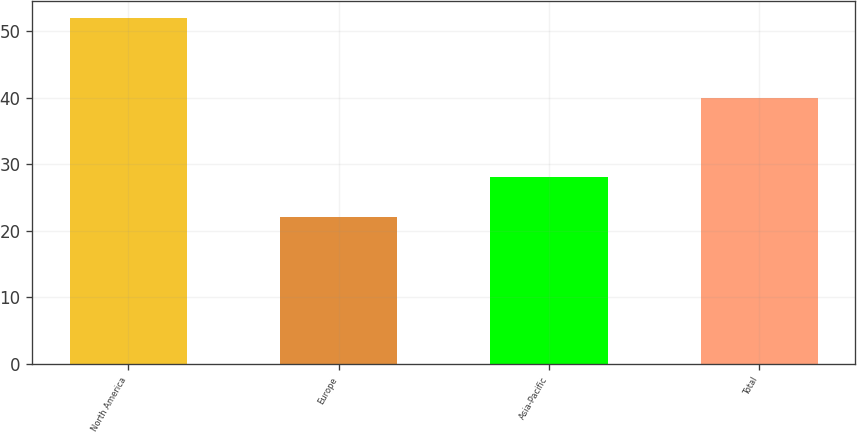Convert chart to OTSL. <chart><loc_0><loc_0><loc_500><loc_500><bar_chart><fcel>North America<fcel>Europe<fcel>Asia-Pacific<fcel>Total<nl><fcel>52<fcel>22<fcel>28<fcel>40<nl></chart> 